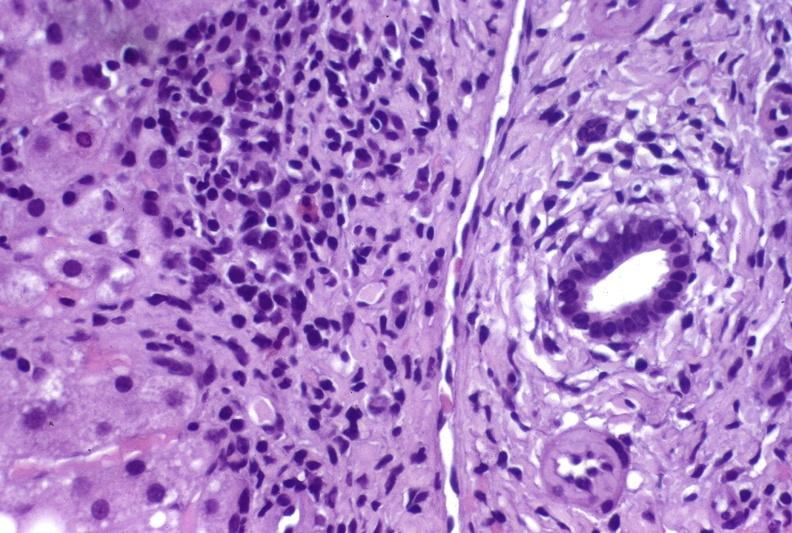s hepatobiliary present?
Answer the question using a single word or phrase. Yes 